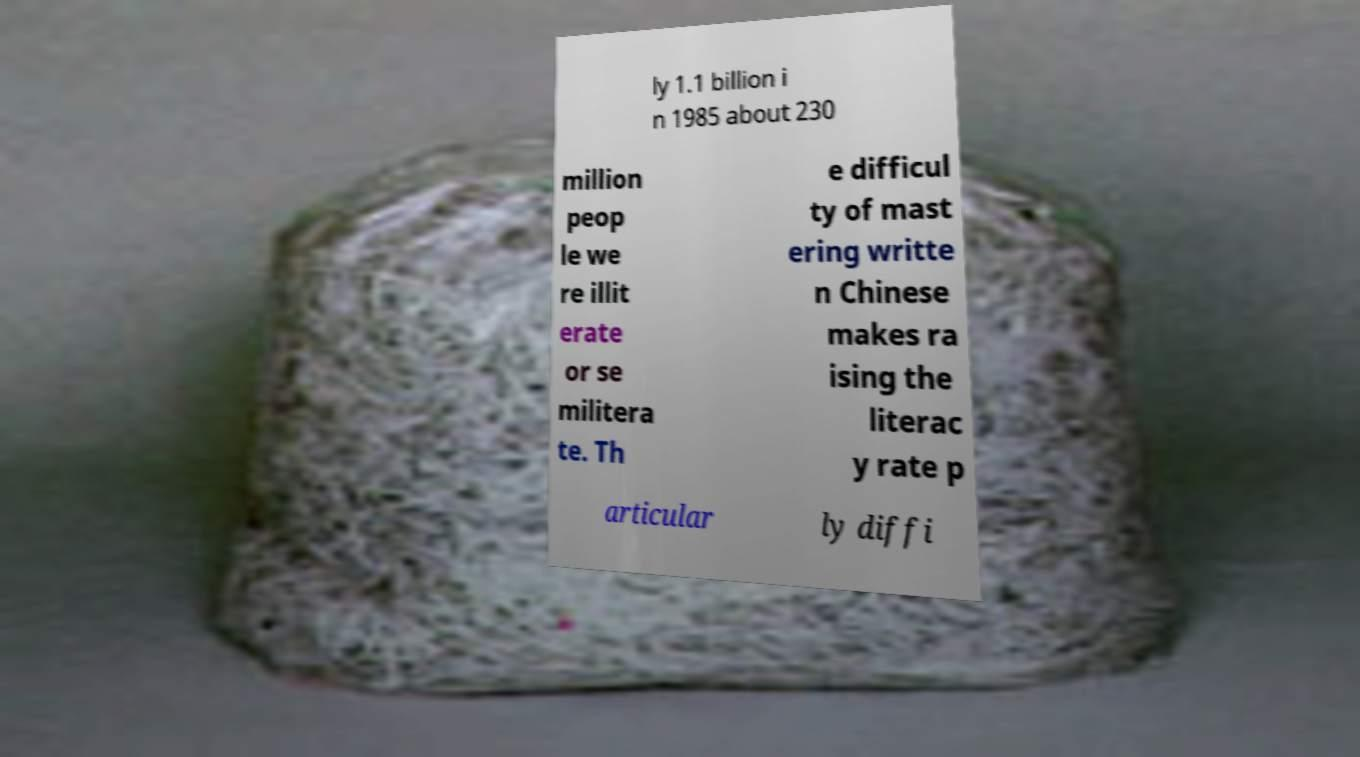Please identify and transcribe the text found in this image. ly 1.1 billion i n 1985 about 230 million peop le we re illit erate or se militera te. Th e difficul ty of mast ering writte n Chinese makes ra ising the literac y rate p articular ly diffi 